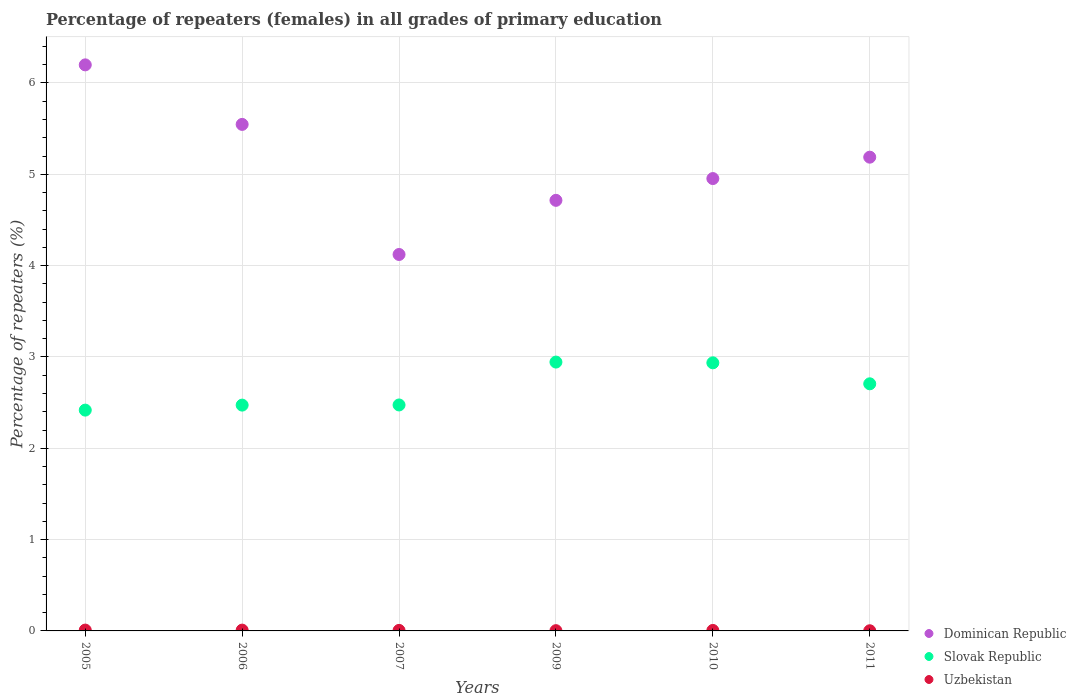How many different coloured dotlines are there?
Offer a terse response. 3. What is the percentage of repeaters (females) in Uzbekistan in 2009?
Offer a terse response. 0. Across all years, what is the maximum percentage of repeaters (females) in Dominican Republic?
Give a very brief answer. 6.2. Across all years, what is the minimum percentage of repeaters (females) in Dominican Republic?
Make the answer very short. 4.12. What is the total percentage of repeaters (females) in Dominican Republic in the graph?
Your response must be concise. 30.72. What is the difference between the percentage of repeaters (females) in Slovak Republic in 2010 and that in 2011?
Ensure brevity in your answer.  0.23. What is the difference between the percentage of repeaters (females) in Uzbekistan in 2005 and the percentage of repeaters (females) in Slovak Republic in 2009?
Provide a succinct answer. -2.93. What is the average percentage of repeaters (females) in Slovak Republic per year?
Provide a short and direct response. 2.66. In the year 2006, what is the difference between the percentage of repeaters (females) in Dominican Republic and percentage of repeaters (females) in Slovak Republic?
Offer a very short reply. 3.07. What is the ratio of the percentage of repeaters (females) in Uzbekistan in 2007 to that in 2010?
Offer a very short reply. 1.07. Is the percentage of repeaters (females) in Slovak Republic in 2005 less than that in 2009?
Make the answer very short. Yes. What is the difference between the highest and the second highest percentage of repeaters (females) in Slovak Republic?
Provide a succinct answer. 0.01. What is the difference between the highest and the lowest percentage of repeaters (females) in Uzbekistan?
Provide a succinct answer. 0.01. In how many years, is the percentage of repeaters (females) in Dominican Republic greater than the average percentage of repeaters (females) in Dominican Republic taken over all years?
Your answer should be compact. 3. Does the percentage of repeaters (females) in Uzbekistan monotonically increase over the years?
Your answer should be very brief. No. Is the percentage of repeaters (females) in Uzbekistan strictly greater than the percentage of repeaters (females) in Dominican Republic over the years?
Provide a short and direct response. No. Are the values on the major ticks of Y-axis written in scientific E-notation?
Your answer should be compact. No. Does the graph contain any zero values?
Make the answer very short. No. Does the graph contain grids?
Provide a succinct answer. Yes. Where does the legend appear in the graph?
Your answer should be very brief. Bottom right. How many legend labels are there?
Your answer should be very brief. 3. What is the title of the graph?
Give a very brief answer. Percentage of repeaters (females) in all grades of primary education. Does "Argentina" appear as one of the legend labels in the graph?
Provide a short and direct response. No. What is the label or title of the X-axis?
Give a very brief answer. Years. What is the label or title of the Y-axis?
Offer a very short reply. Percentage of repeaters (%). What is the Percentage of repeaters (%) of Dominican Republic in 2005?
Your answer should be very brief. 6.2. What is the Percentage of repeaters (%) in Slovak Republic in 2005?
Offer a very short reply. 2.42. What is the Percentage of repeaters (%) of Uzbekistan in 2005?
Offer a terse response. 0.01. What is the Percentage of repeaters (%) of Dominican Republic in 2006?
Provide a succinct answer. 5.55. What is the Percentage of repeaters (%) in Slovak Republic in 2006?
Provide a short and direct response. 2.47. What is the Percentage of repeaters (%) in Uzbekistan in 2006?
Your response must be concise. 0.01. What is the Percentage of repeaters (%) in Dominican Republic in 2007?
Ensure brevity in your answer.  4.12. What is the Percentage of repeaters (%) of Slovak Republic in 2007?
Make the answer very short. 2.47. What is the Percentage of repeaters (%) of Uzbekistan in 2007?
Your response must be concise. 0.01. What is the Percentage of repeaters (%) in Dominican Republic in 2009?
Offer a terse response. 4.71. What is the Percentage of repeaters (%) in Slovak Republic in 2009?
Make the answer very short. 2.94. What is the Percentage of repeaters (%) of Uzbekistan in 2009?
Offer a terse response. 0. What is the Percentage of repeaters (%) of Dominican Republic in 2010?
Keep it short and to the point. 4.95. What is the Percentage of repeaters (%) of Slovak Republic in 2010?
Give a very brief answer. 2.94. What is the Percentage of repeaters (%) of Uzbekistan in 2010?
Keep it short and to the point. 0.01. What is the Percentage of repeaters (%) in Dominican Republic in 2011?
Offer a very short reply. 5.19. What is the Percentage of repeaters (%) in Slovak Republic in 2011?
Your answer should be very brief. 2.71. What is the Percentage of repeaters (%) in Uzbekistan in 2011?
Offer a terse response. 0. Across all years, what is the maximum Percentage of repeaters (%) in Dominican Republic?
Give a very brief answer. 6.2. Across all years, what is the maximum Percentage of repeaters (%) of Slovak Republic?
Make the answer very short. 2.94. Across all years, what is the maximum Percentage of repeaters (%) in Uzbekistan?
Provide a short and direct response. 0.01. Across all years, what is the minimum Percentage of repeaters (%) in Dominican Republic?
Your response must be concise. 4.12. Across all years, what is the minimum Percentage of repeaters (%) of Slovak Republic?
Ensure brevity in your answer.  2.42. Across all years, what is the minimum Percentage of repeaters (%) in Uzbekistan?
Provide a succinct answer. 0. What is the total Percentage of repeaters (%) of Dominican Republic in the graph?
Your answer should be compact. 30.72. What is the total Percentage of repeaters (%) in Slovak Republic in the graph?
Make the answer very short. 15.95. What is the total Percentage of repeaters (%) of Uzbekistan in the graph?
Your response must be concise. 0.03. What is the difference between the Percentage of repeaters (%) of Dominican Republic in 2005 and that in 2006?
Keep it short and to the point. 0.65. What is the difference between the Percentage of repeaters (%) of Slovak Republic in 2005 and that in 2006?
Your answer should be very brief. -0.05. What is the difference between the Percentage of repeaters (%) in Dominican Republic in 2005 and that in 2007?
Your answer should be compact. 2.08. What is the difference between the Percentage of repeaters (%) in Slovak Republic in 2005 and that in 2007?
Offer a terse response. -0.06. What is the difference between the Percentage of repeaters (%) in Uzbekistan in 2005 and that in 2007?
Your response must be concise. 0. What is the difference between the Percentage of repeaters (%) in Dominican Republic in 2005 and that in 2009?
Your response must be concise. 1.48. What is the difference between the Percentage of repeaters (%) in Slovak Republic in 2005 and that in 2009?
Your response must be concise. -0.53. What is the difference between the Percentage of repeaters (%) in Uzbekistan in 2005 and that in 2009?
Give a very brief answer. 0.01. What is the difference between the Percentage of repeaters (%) in Dominican Republic in 2005 and that in 2010?
Provide a succinct answer. 1.24. What is the difference between the Percentage of repeaters (%) of Slovak Republic in 2005 and that in 2010?
Your answer should be compact. -0.52. What is the difference between the Percentage of repeaters (%) in Uzbekistan in 2005 and that in 2010?
Give a very brief answer. 0. What is the difference between the Percentage of repeaters (%) of Dominican Republic in 2005 and that in 2011?
Your response must be concise. 1.01. What is the difference between the Percentage of repeaters (%) of Slovak Republic in 2005 and that in 2011?
Offer a very short reply. -0.29. What is the difference between the Percentage of repeaters (%) in Uzbekistan in 2005 and that in 2011?
Offer a terse response. 0.01. What is the difference between the Percentage of repeaters (%) in Dominican Republic in 2006 and that in 2007?
Give a very brief answer. 1.42. What is the difference between the Percentage of repeaters (%) of Slovak Republic in 2006 and that in 2007?
Give a very brief answer. -0. What is the difference between the Percentage of repeaters (%) of Uzbekistan in 2006 and that in 2007?
Your answer should be compact. 0. What is the difference between the Percentage of repeaters (%) of Dominican Republic in 2006 and that in 2009?
Your answer should be compact. 0.83. What is the difference between the Percentage of repeaters (%) in Slovak Republic in 2006 and that in 2009?
Provide a short and direct response. -0.47. What is the difference between the Percentage of repeaters (%) in Uzbekistan in 2006 and that in 2009?
Provide a short and direct response. 0.01. What is the difference between the Percentage of repeaters (%) of Dominican Republic in 2006 and that in 2010?
Your answer should be very brief. 0.59. What is the difference between the Percentage of repeaters (%) in Slovak Republic in 2006 and that in 2010?
Your answer should be compact. -0.46. What is the difference between the Percentage of repeaters (%) in Uzbekistan in 2006 and that in 2010?
Give a very brief answer. 0. What is the difference between the Percentage of repeaters (%) of Dominican Republic in 2006 and that in 2011?
Make the answer very short. 0.36. What is the difference between the Percentage of repeaters (%) of Slovak Republic in 2006 and that in 2011?
Ensure brevity in your answer.  -0.23. What is the difference between the Percentage of repeaters (%) in Uzbekistan in 2006 and that in 2011?
Ensure brevity in your answer.  0.01. What is the difference between the Percentage of repeaters (%) in Dominican Republic in 2007 and that in 2009?
Keep it short and to the point. -0.59. What is the difference between the Percentage of repeaters (%) in Slovak Republic in 2007 and that in 2009?
Offer a terse response. -0.47. What is the difference between the Percentage of repeaters (%) of Uzbekistan in 2007 and that in 2009?
Ensure brevity in your answer.  0. What is the difference between the Percentage of repeaters (%) in Dominican Republic in 2007 and that in 2010?
Offer a terse response. -0.83. What is the difference between the Percentage of repeaters (%) of Slovak Republic in 2007 and that in 2010?
Provide a short and direct response. -0.46. What is the difference between the Percentage of repeaters (%) in Dominican Republic in 2007 and that in 2011?
Your answer should be compact. -1.07. What is the difference between the Percentage of repeaters (%) of Slovak Republic in 2007 and that in 2011?
Keep it short and to the point. -0.23. What is the difference between the Percentage of repeaters (%) in Uzbekistan in 2007 and that in 2011?
Offer a very short reply. 0. What is the difference between the Percentage of repeaters (%) of Dominican Republic in 2009 and that in 2010?
Ensure brevity in your answer.  -0.24. What is the difference between the Percentage of repeaters (%) in Slovak Republic in 2009 and that in 2010?
Keep it short and to the point. 0.01. What is the difference between the Percentage of repeaters (%) in Uzbekistan in 2009 and that in 2010?
Keep it short and to the point. -0. What is the difference between the Percentage of repeaters (%) of Dominican Republic in 2009 and that in 2011?
Make the answer very short. -0.47. What is the difference between the Percentage of repeaters (%) of Slovak Republic in 2009 and that in 2011?
Give a very brief answer. 0.24. What is the difference between the Percentage of repeaters (%) of Uzbekistan in 2009 and that in 2011?
Offer a very short reply. 0. What is the difference between the Percentage of repeaters (%) of Dominican Republic in 2010 and that in 2011?
Your response must be concise. -0.23. What is the difference between the Percentage of repeaters (%) in Slovak Republic in 2010 and that in 2011?
Your answer should be very brief. 0.23. What is the difference between the Percentage of repeaters (%) in Uzbekistan in 2010 and that in 2011?
Keep it short and to the point. 0. What is the difference between the Percentage of repeaters (%) in Dominican Republic in 2005 and the Percentage of repeaters (%) in Slovak Republic in 2006?
Your answer should be very brief. 3.73. What is the difference between the Percentage of repeaters (%) of Dominican Republic in 2005 and the Percentage of repeaters (%) of Uzbekistan in 2006?
Make the answer very short. 6.19. What is the difference between the Percentage of repeaters (%) of Slovak Republic in 2005 and the Percentage of repeaters (%) of Uzbekistan in 2006?
Offer a terse response. 2.41. What is the difference between the Percentage of repeaters (%) of Dominican Republic in 2005 and the Percentage of repeaters (%) of Slovak Republic in 2007?
Offer a very short reply. 3.72. What is the difference between the Percentage of repeaters (%) of Dominican Republic in 2005 and the Percentage of repeaters (%) of Uzbekistan in 2007?
Make the answer very short. 6.19. What is the difference between the Percentage of repeaters (%) in Slovak Republic in 2005 and the Percentage of repeaters (%) in Uzbekistan in 2007?
Ensure brevity in your answer.  2.41. What is the difference between the Percentage of repeaters (%) in Dominican Republic in 2005 and the Percentage of repeaters (%) in Slovak Republic in 2009?
Keep it short and to the point. 3.25. What is the difference between the Percentage of repeaters (%) in Dominican Republic in 2005 and the Percentage of repeaters (%) in Uzbekistan in 2009?
Keep it short and to the point. 6.2. What is the difference between the Percentage of repeaters (%) of Slovak Republic in 2005 and the Percentage of repeaters (%) of Uzbekistan in 2009?
Provide a short and direct response. 2.42. What is the difference between the Percentage of repeaters (%) in Dominican Republic in 2005 and the Percentage of repeaters (%) in Slovak Republic in 2010?
Provide a short and direct response. 3.26. What is the difference between the Percentage of repeaters (%) in Dominican Republic in 2005 and the Percentage of repeaters (%) in Uzbekistan in 2010?
Make the answer very short. 6.19. What is the difference between the Percentage of repeaters (%) of Slovak Republic in 2005 and the Percentage of repeaters (%) of Uzbekistan in 2010?
Your answer should be very brief. 2.41. What is the difference between the Percentage of repeaters (%) of Dominican Republic in 2005 and the Percentage of repeaters (%) of Slovak Republic in 2011?
Your answer should be compact. 3.49. What is the difference between the Percentage of repeaters (%) in Dominican Republic in 2005 and the Percentage of repeaters (%) in Uzbekistan in 2011?
Provide a succinct answer. 6.2. What is the difference between the Percentage of repeaters (%) of Slovak Republic in 2005 and the Percentage of repeaters (%) of Uzbekistan in 2011?
Make the answer very short. 2.42. What is the difference between the Percentage of repeaters (%) in Dominican Republic in 2006 and the Percentage of repeaters (%) in Slovak Republic in 2007?
Offer a terse response. 3.07. What is the difference between the Percentage of repeaters (%) of Dominican Republic in 2006 and the Percentage of repeaters (%) of Uzbekistan in 2007?
Make the answer very short. 5.54. What is the difference between the Percentage of repeaters (%) in Slovak Republic in 2006 and the Percentage of repeaters (%) in Uzbekistan in 2007?
Make the answer very short. 2.47. What is the difference between the Percentage of repeaters (%) of Dominican Republic in 2006 and the Percentage of repeaters (%) of Slovak Republic in 2009?
Provide a short and direct response. 2.6. What is the difference between the Percentage of repeaters (%) in Dominican Republic in 2006 and the Percentage of repeaters (%) in Uzbekistan in 2009?
Your response must be concise. 5.54. What is the difference between the Percentage of repeaters (%) of Slovak Republic in 2006 and the Percentage of repeaters (%) of Uzbekistan in 2009?
Ensure brevity in your answer.  2.47. What is the difference between the Percentage of repeaters (%) of Dominican Republic in 2006 and the Percentage of repeaters (%) of Slovak Republic in 2010?
Provide a succinct answer. 2.61. What is the difference between the Percentage of repeaters (%) of Dominican Republic in 2006 and the Percentage of repeaters (%) of Uzbekistan in 2010?
Your answer should be very brief. 5.54. What is the difference between the Percentage of repeaters (%) of Slovak Republic in 2006 and the Percentage of repeaters (%) of Uzbekistan in 2010?
Keep it short and to the point. 2.47. What is the difference between the Percentage of repeaters (%) of Dominican Republic in 2006 and the Percentage of repeaters (%) of Slovak Republic in 2011?
Your answer should be very brief. 2.84. What is the difference between the Percentage of repeaters (%) in Dominican Republic in 2006 and the Percentage of repeaters (%) in Uzbekistan in 2011?
Offer a terse response. 5.54. What is the difference between the Percentage of repeaters (%) of Slovak Republic in 2006 and the Percentage of repeaters (%) of Uzbekistan in 2011?
Keep it short and to the point. 2.47. What is the difference between the Percentage of repeaters (%) in Dominican Republic in 2007 and the Percentage of repeaters (%) in Slovak Republic in 2009?
Your answer should be compact. 1.18. What is the difference between the Percentage of repeaters (%) of Dominican Republic in 2007 and the Percentage of repeaters (%) of Uzbekistan in 2009?
Keep it short and to the point. 4.12. What is the difference between the Percentage of repeaters (%) of Slovak Republic in 2007 and the Percentage of repeaters (%) of Uzbekistan in 2009?
Give a very brief answer. 2.47. What is the difference between the Percentage of repeaters (%) in Dominican Republic in 2007 and the Percentage of repeaters (%) in Slovak Republic in 2010?
Make the answer very short. 1.19. What is the difference between the Percentage of repeaters (%) of Dominican Republic in 2007 and the Percentage of repeaters (%) of Uzbekistan in 2010?
Offer a very short reply. 4.12. What is the difference between the Percentage of repeaters (%) in Slovak Republic in 2007 and the Percentage of repeaters (%) in Uzbekistan in 2010?
Your answer should be very brief. 2.47. What is the difference between the Percentage of repeaters (%) in Dominican Republic in 2007 and the Percentage of repeaters (%) in Slovak Republic in 2011?
Ensure brevity in your answer.  1.42. What is the difference between the Percentage of repeaters (%) in Dominican Republic in 2007 and the Percentage of repeaters (%) in Uzbekistan in 2011?
Ensure brevity in your answer.  4.12. What is the difference between the Percentage of repeaters (%) of Slovak Republic in 2007 and the Percentage of repeaters (%) of Uzbekistan in 2011?
Your answer should be compact. 2.47. What is the difference between the Percentage of repeaters (%) of Dominican Republic in 2009 and the Percentage of repeaters (%) of Slovak Republic in 2010?
Ensure brevity in your answer.  1.78. What is the difference between the Percentage of repeaters (%) in Dominican Republic in 2009 and the Percentage of repeaters (%) in Uzbekistan in 2010?
Offer a terse response. 4.71. What is the difference between the Percentage of repeaters (%) of Slovak Republic in 2009 and the Percentage of repeaters (%) of Uzbekistan in 2010?
Provide a succinct answer. 2.94. What is the difference between the Percentage of repeaters (%) of Dominican Republic in 2009 and the Percentage of repeaters (%) of Slovak Republic in 2011?
Your answer should be compact. 2.01. What is the difference between the Percentage of repeaters (%) of Dominican Republic in 2009 and the Percentage of repeaters (%) of Uzbekistan in 2011?
Offer a very short reply. 4.71. What is the difference between the Percentage of repeaters (%) in Slovak Republic in 2009 and the Percentage of repeaters (%) in Uzbekistan in 2011?
Offer a very short reply. 2.94. What is the difference between the Percentage of repeaters (%) in Dominican Republic in 2010 and the Percentage of repeaters (%) in Slovak Republic in 2011?
Ensure brevity in your answer.  2.25. What is the difference between the Percentage of repeaters (%) in Dominican Republic in 2010 and the Percentage of repeaters (%) in Uzbekistan in 2011?
Provide a succinct answer. 4.95. What is the difference between the Percentage of repeaters (%) in Slovak Republic in 2010 and the Percentage of repeaters (%) in Uzbekistan in 2011?
Provide a short and direct response. 2.93. What is the average Percentage of repeaters (%) in Dominican Republic per year?
Your answer should be compact. 5.12. What is the average Percentage of repeaters (%) in Slovak Republic per year?
Give a very brief answer. 2.66. What is the average Percentage of repeaters (%) in Uzbekistan per year?
Your answer should be compact. 0.01. In the year 2005, what is the difference between the Percentage of repeaters (%) in Dominican Republic and Percentage of repeaters (%) in Slovak Republic?
Ensure brevity in your answer.  3.78. In the year 2005, what is the difference between the Percentage of repeaters (%) of Dominican Republic and Percentage of repeaters (%) of Uzbekistan?
Give a very brief answer. 6.19. In the year 2005, what is the difference between the Percentage of repeaters (%) in Slovak Republic and Percentage of repeaters (%) in Uzbekistan?
Make the answer very short. 2.41. In the year 2006, what is the difference between the Percentage of repeaters (%) in Dominican Republic and Percentage of repeaters (%) in Slovak Republic?
Your answer should be very brief. 3.07. In the year 2006, what is the difference between the Percentage of repeaters (%) of Dominican Republic and Percentage of repeaters (%) of Uzbekistan?
Make the answer very short. 5.54. In the year 2006, what is the difference between the Percentage of repeaters (%) in Slovak Republic and Percentage of repeaters (%) in Uzbekistan?
Give a very brief answer. 2.46. In the year 2007, what is the difference between the Percentage of repeaters (%) of Dominican Republic and Percentage of repeaters (%) of Slovak Republic?
Your answer should be compact. 1.65. In the year 2007, what is the difference between the Percentage of repeaters (%) of Dominican Republic and Percentage of repeaters (%) of Uzbekistan?
Your answer should be very brief. 4.12. In the year 2007, what is the difference between the Percentage of repeaters (%) in Slovak Republic and Percentage of repeaters (%) in Uzbekistan?
Offer a very short reply. 2.47. In the year 2009, what is the difference between the Percentage of repeaters (%) of Dominican Republic and Percentage of repeaters (%) of Slovak Republic?
Offer a terse response. 1.77. In the year 2009, what is the difference between the Percentage of repeaters (%) of Dominican Republic and Percentage of repeaters (%) of Uzbekistan?
Ensure brevity in your answer.  4.71. In the year 2009, what is the difference between the Percentage of repeaters (%) of Slovak Republic and Percentage of repeaters (%) of Uzbekistan?
Ensure brevity in your answer.  2.94. In the year 2010, what is the difference between the Percentage of repeaters (%) of Dominican Republic and Percentage of repeaters (%) of Slovak Republic?
Give a very brief answer. 2.02. In the year 2010, what is the difference between the Percentage of repeaters (%) in Dominican Republic and Percentage of repeaters (%) in Uzbekistan?
Your answer should be compact. 4.95. In the year 2010, what is the difference between the Percentage of repeaters (%) of Slovak Republic and Percentage of repeaters (%) of Uzbekistan?
Your answer should be very brief. 2.93. In the year 2011, what is the difference between the Percentage of repeaters (%) in Dominican Republic and Percentage of repeaters (%) in Slovak Republic?
Provide a short and direct response. 2.48. In the year 2011, what is the difference between the Percentage of repeaters (%) of Dominican Republic and Percentage of repeaters (%) of Uzbekistan?
Your answer should be very brief. 5.19. In the year 2011, what is the difference between the Percentage of repeaters (%) of Slovak Republic and Percentage of repeaters (%) of Uzbekistan?
Offer a very short reply. 2.7. What is the ratio of the Percentage of repeaters (%) of Dominican Republic in 2005 to that in 2006?
Provide a short and direct response. 1.12. What is the ratio of the Percentage of repeaters (%) in Slovak Republic in 2005 to that in 2006?
Ensure brevity in your answer.  0.98. What is the ratio of the Percentage of repeaters (%) of Uzbekistan in 2005 to that in 2006?
Your answer should be compact. 1.04. What is the ratio of the Percentage of repeaters (%) of Dominican Republic in 2005 to that in 2007?
Provide a succinct answer. 1.5. What is the ratio of the Percentage of repeaters (%) of Slovak Republic in 2005 to that in 2007?
Offer a terse response. 0.98. What is the ratio of the Percentage of repeaters (%) of Uzbekistan in 2005 to that in 2007?
Your answer should be very brief. 1.6. What is the ratio of the Percentage of repeaters (%) of Dominican Republic in 2005 to that in 2009?
Offer a very short reply. 1.31. What is the ratio of the Percentage of repeaters (%) in Slovak Republic in 2005 to that in 2009?
Make the answer very short. 0.82. What is the ratio of the Percentage of repeaters (%) in Uzbekistan in 2005 to that in 2009?
Offer a very short reply. 3.28. What is the ratio of the Percentage of repeaters (%) in Dominican Republic in 2005 to that in 2010?
Offer a terse response. 1.25. What is the ratio of the Percentage of repeaters (%) in Slovak Republic in 2005 to that in 2010?
Provide a succinct answer. 0.82. What is the ratio of the Percentage of repeaters (%) of Uzbekistan in 2005 to that in 2010?
Your answer should be very brief. 1.71. What is the ratio of the Percentage of repeaters (%) of Dominican Republic in 2005 to that in 2011?
Ensure brevity in your answer.  1.19. What is the ratio of the Percentage of repeaters (%) of Slovak Republic in 2005 to that in 2011?
Keep it short and to the point. 0.89. What is the ratio of the Percentage of repeaters (%) of Uzbekistan in 2005 to that in 2011?
Your answer should be very brief. 5.08. What is the ratio of the Percentage of repeaters (%) in Dominican Republic in 2006 to that in 2007?
Provide a short and direct response. 1.35. What is the ratio of the Percentage of repeaters (%) of Slovak Republic in 2006 to that in 2007?
Keep it short and to the point. 1. What is the ratio of the Percentage of repeaters (%) of Uzbekistan in 2006 to that in 2007?
Ensure brevity in your answer.  1.53. What is the ratio of the Percentage of repeaters (%) of Dominican Republic in 2006 to that in 2009?
Your response must be concise. 1.18. What is the ratio of the Percentage of repeaters (%) of Slovak Republic in 2006 to that in 2009?
Offer a terse response. 0.84. What is the ratio of the Percentage of repeaters (%) of Uzbekistan in 2006 to that in 2009?
Provide a succinct answer. 3.14. What is the ratio of the Percentage of repeaters (%) of Dominican Republic in 2006 to that in 2010?
Your response must be concise. 1.12. What is the ratio of the Percentage of repeaters (%) in Slovak Republic in 2006 to that in 2010?
Your answer should be compact. 0.84. What is the ratio of the Percentage of repeaters (%) of Uzbekistan in 2006 to that in 2010?
Offer a very short reply. 1.64. What is the ratio of the Percentage of repeaters (%) of Dominican Republic in 2006 to that in 2011?
Provide a succinct answer. 1.07. What is the ratio of the Percentage of repeaters (%) in Slovak Republic in 2006 to that in 2011?
Give a very brief answer. 0.91. What is the ratio of the Percentage of repeaters (%) of Uzbekistan in 2006 to that in 2011?
Your answer should be compact. 4.87. What is the ratio of the Percentage of repeaters (%) in Dominican Republic in 2007 to that in 2009?
Provide a succinct answer. 0.87. What is the ratio of the Percentage of repeaters (%) in Slovak Republic in 2007 to that in 2009?
Provide a short and direct response. 0.84. What is the ratio of the Percentage of repeaters (%) in Uzbekistan in 2007 to that in 2009?
Your response must be concise. 2.05. What is the ratio of the Percentage of repeaters (%) in Dominican Republic in 2007 to that in 2010?
Make the answer very short. 0.83. What is the ratio of the Percentage of repeaters (%) in Slovak Republic in 2007 to that in 2010?
Your response must be concise. 0.84. What is the ratio of the Percentage of repeaters (%) of Uzbekistan in 2007 to that in 2010?
Give a very brief answer. 1.07. What is the ratio of the Percentage of repeaters (%) of Dominican Republic in 2007 to that in 2011?
Your response must be concise. 0.79. What is the ratio of the Percentage of repeaters (%) in Slovak Republic in 2007 to that in 2011?
Your response must be concise. 0.91. What is the ratio of the Percentage of repeaters (%) of Uzbekistan in 2007 to that in 2011?
Give a very brief answer. 3.17. What is the ratio of the Percentage of repeaters (%) in Dominican Republic in 2009 to that in 2010?
Your answer should be very brief. 0.95. What is the ratio of the Percentage of repeaters (%) in Uzbekistan in 2009 to that in 2010?
Your answer should be very brief. 0.52. What is the ratio of the Percentage of repeaters (%) in Dominican Republic in 2009 to that in 2011?
Make the answer very short. 0.91. What is the ratio of the Percentage of repeaters (%) in Slovak Republic in 2009 to that in 2011?
Ensure brevity in your answer.  1.09. What is the ratio of the Percentage of repeaters (%) in Uzbekistan in 2009 to that in 2011?
Offer a terse response. 1.55. What is the ratio of the Percentage of repeaters (%) in Dominican Republic in 2010 to that in 2011?
Provide a succinct answer. 0.95. What is the ratio of the Percentage of repeaters (%) of Slovak Republic in 2010 to that in 2011?
Provide a succinct answer. 1.08. What is the ratio of the Percentage of repeaters (%) in Uzbekistan in 2010 to that in 2011?
Your answer should be very brief. 2.97. What is the difference between the highest and the second highest Percentage of repeaters (%) in Dominican Republic?
Keep it short and to the point. 0.65. What is the difference between the highest and the second highest Percentage of repeaters (%) in Slovak Republic?
Your response must be concise. 0.01. What is the difference between the highest and the lowest Percentage of repeaters (%) in Dominican Republic?
Make the answer very short. 2.08. What is the difference between the highest and the lowest Percentage of repeaters (%) in Slovak Republic?
Keep it short and to the point. 0.53. What is the difference between the highest and the lowest Percentage of repeaters (%) in Uzbekistan?
Make the answer very short. 0.01. 